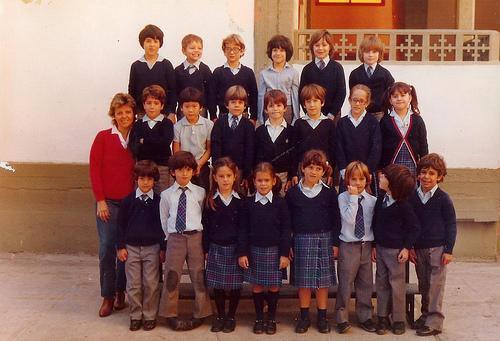How many people can be seen?
Give a very brief answer. 13. 